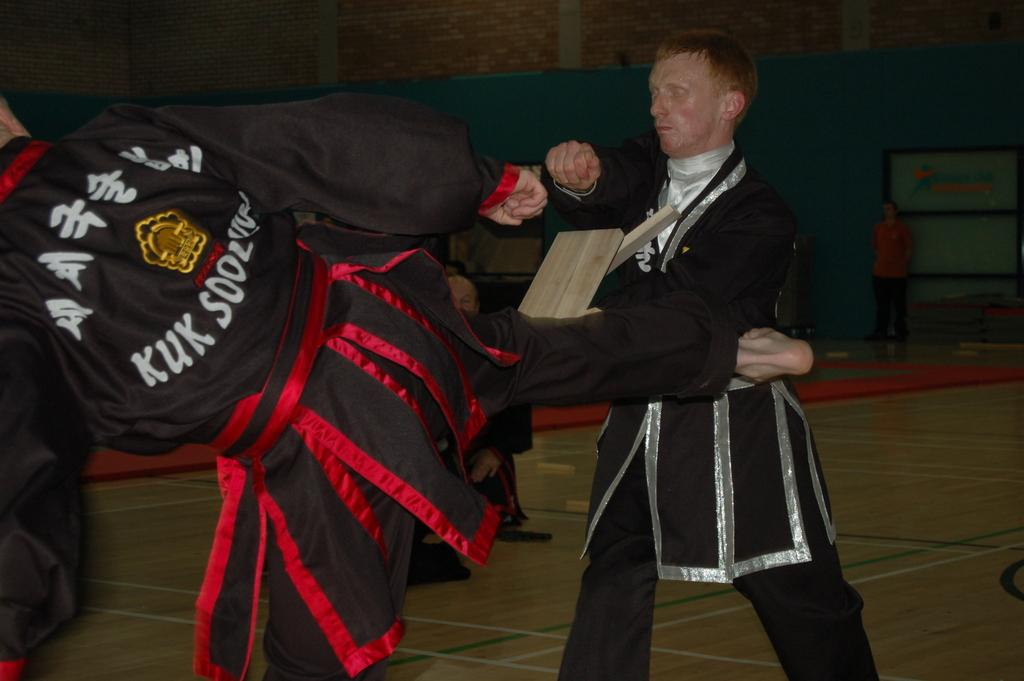Provide a one-sentence caption for the provided image. a man kicking a person with kuk written on his back. 